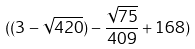<formula> <loc_0><loc_0><loc_500><loc_500>( ( 3 - \sqrt { 4 2 0 } ) - \frac { \sqrt { 7 5 } } { 4 0 9 } + 1 6 8 )</formula> 